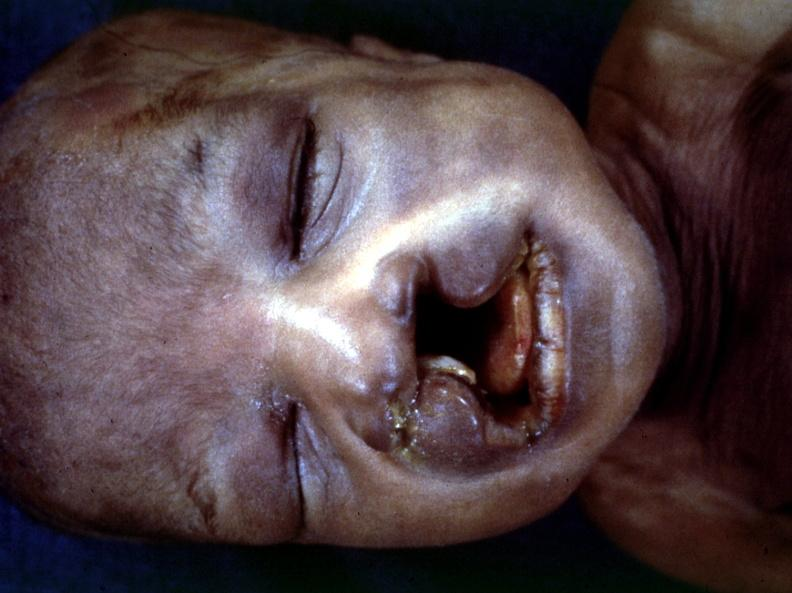s face present?
Answer the question using a single word or phrase. Yes 